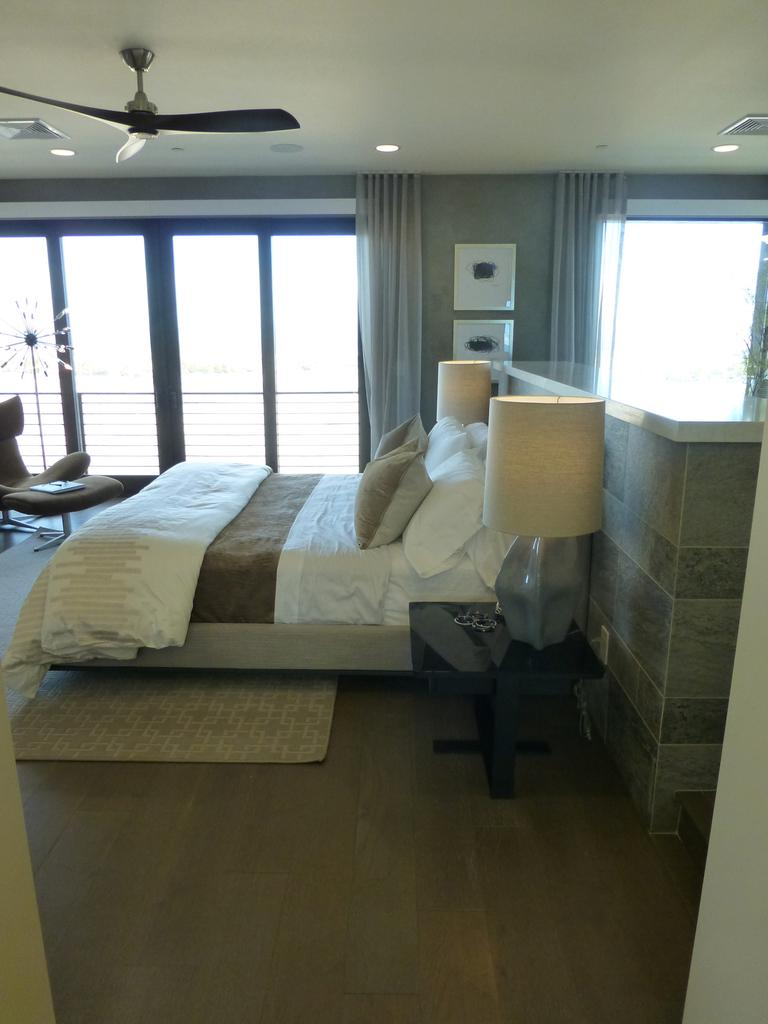What type of furniture is present in the image? There is a bed, lamps, a light, a fan, and a chair in the image. What is on the bed in the image? The bed has a blanket and pillows in the image. Can you describe the lighting in the image? There are lamps and a light in the image. Where is the fan located in the image? The fan is on the roof in the image. What type of nest can be seen in the image? There is no nest present in the image. What is the rod used for in the image? There is no rod present in the image. 